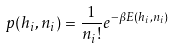Convert formula to latex. <formula><loc_0><loc_0><loc_500><loc_500>p ( h _ { i } , n _ { i } ) = \frac { 1 } { n _ { i } ! } e ^ { - \beta E ( h _ { i } , n _ { i } ) }</formula> 